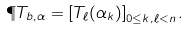<formula> <loc_0><loc_0><loc_500><loc_500>\P T _ { b , \alpha } = \left [ T _ { \ell } ( \alpha _ { k } ) \right ] _ { 0 \leq k , \ell < n } .</formula> 